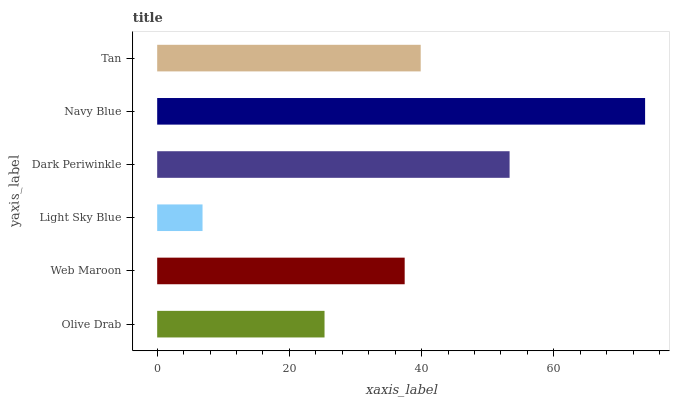Is Light Sky Blue the minimum?
Answer yes or no. Yes. Is Navy Blue the maximum?
Answer yes or no. Yes. Is Web Maroon the minimum?
Answer yes or no. No. Is Web Maroon the maximum?
Answer yes or no. No. Is Web Maroon greater than Olive Drab?
Answer yes or no. Yes. Is Olive Drab less than Web Maroon?
Answer yes or no. Yes. Is Olive Drab greater than Web Maroon?
Answer yes or no. No. Is Web Maroon less than Olive Drab?
Answer yes or no. No. Is Tan the high median?
Answer yes or no. Yes. Is Web Maroon the low median?
Answer yes or no. Yes. Is Web Maroon the high median?
Answer yes or no. No. Is Navy Blue the low median?
Answer yes or no. No. 